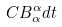Convert formula to latex. <formula><loc_0><loc_0><loc_500><loc_500>C B _ { \alpha } ^ { \alpha } d t</formula> 